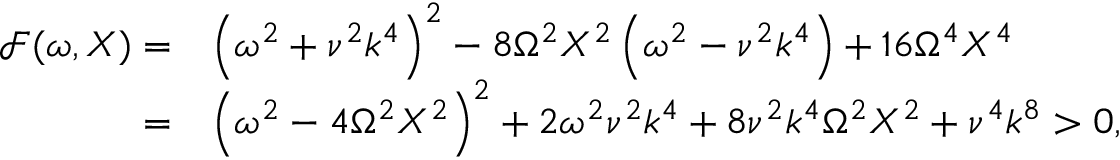<formula> <loc_0><loc_0><loc_500><loc_500>\begin{array} { r l } { \mathcal { F } ( \omega , X ) = } & { \left ( \omega ^ { 2 } + \nu ^ { 2 } k ^ { 4 } \right ) ^ { 2 } - 8 \Omega ^ { 2 } X ^ { 2 } \left ( \omega ^ { 2 } - \nu ^ { 2 } k ^ { 4 } \right ) + 1 6 \Omega ^ { 4 } X ^ { 4 } } \\ { = } & { \left ( \omega ^ { 2 } - 4 \Omega ^ { 2 } X ^ { 2 } \right ) ^ { 2 } + 2 \omega ^ { 2 } \nu ^ { 2 } k ^ { 4 } + 8 \nu ^ { 2 } k ^ { 4 } \Omega ^ { 2 } X ^ { 2 } + \nu ^ { 4 } k ^ { 8 } > 0 , } \end{array}</formula> 